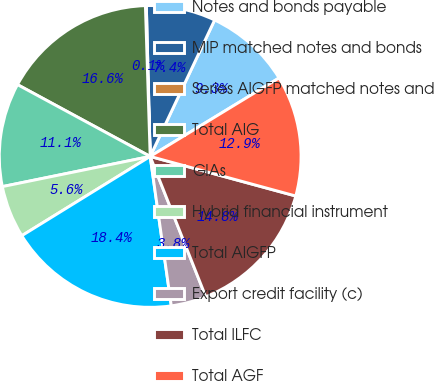Convert chart to OTSL. <chart><loc_0><loc_0><loc_500><loc_500><pie_chart><fcel>Notes and bonds payable<fcel>MIP matched notes and bonds<fcel>Series AIGFP matched notes and<fcel>Total AIG<fcel>GIAs<fcel>Hybrid financial instrument<fcel>Total AIGFP<fcel>Export credit facility (c)<fcel>Total ILFC<fcel>Total AGF<nl><fcel>9.27%<fcel>7.43%<fcel>0.1%<fcel>16.6%<fcel>11.1%<fcel>5.6%<fcel>18.43%<fcel>3.77%<fcel>14.77%<fcel>12.93%<nl></chart> 